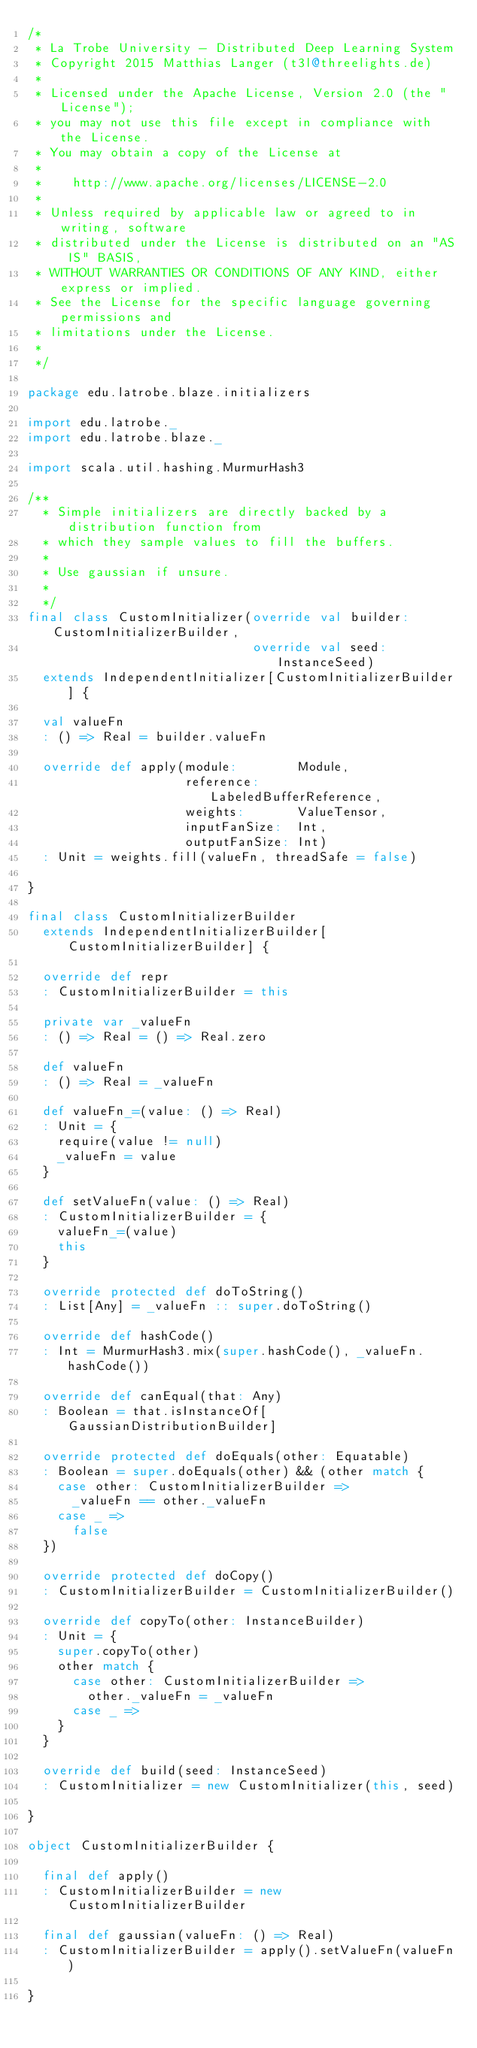<code> <loc_0><loc_0><loc_500><loc_500><_Scala_>/*
 * La Trobe University - Distributed Deep Learning System
 * Copyright 2015 Matthias Langer (t3l@threelights.de)
 *
 * Licensed under the Apache License, Version 2.0 (the "License");
 * you may not use this file except in compliance with the License.
 * You may obtain a copy of the License at
 *
 *    http://www.apache.org/licenses/LICENSE-2.0
 *
 * Unless required by applicable law or agreed to in writing, software
 * distributed under the License is distributed on an "AS IS" BASIS,
 * WITHOUT WARRANTIES OR CONDITIONS OF ANY KIND, either express or implied.
 * See the License for the specific language governing permissions and
 * limitations under the License.
 *
 */

package edu.latrobe.blaze.initializers

import edu.latrobe._
import edu.latrobe.blaze._

import scala.util.hashing.MurmurHash3

/**
  * Simple initializers are directly backed by a distribution function from
  * which they sample values to fill the buffers.
  *
  * Use gaussian if unsure.
  *
  */
final class CustomInitializer(override val builder: CustomInitializerBuilder,
                              override val seed:    InstanceSeed)
  extends IndependentInitializer[CustomInitializerBuilder] {

  val valueFn
  : () => Real = builder.valueFn

  override def apply(module:        Module,
                     reference:     LabeledBufferReference,
                     weights:       ValueTensor,
                     inputFanSize:  Int,
                     outputFanSize: Int)
  : Unit = weights.fill(valueFn, threadSafe = false)

}

final class CustomInitializerBuilder
  extends IndependentInitializerBuilder[CustomInitializerBuilder] {

  override def repr
  : CustomInitializerBuilder = this

  private var _valueFn
  : () => Real = () => Real.zero

  def valueFn
  : () => Real = _valueFn

  def valueFn_=(value: () => Real)
  : Unit = {
    require(value != null)
    _valueFn = value
  }

  def setValueFn(value: () => Real)
  : CustomInitializerBuilder = {
    valueFn_=(value)
    this
  }

  override protected def doToString()
  : List[Any] = _valueFn :: super.doToString()

  override def hashCode()
  : Int = MurmurHash3.mix(super.hashCode(), _valueFn.hashCode())

  override def canEqual(that: Any)
  : Boolean = that.isInstanceOf[GaussianDistributionBuilder]

  override protected def doEquals(other: Equatable)
  : Boolean = super.doEquals(other) && (other match {
    case other: CustomInitializerBuilder =>
      _valueFn == other._valueFn
    case _ =>
      false
  })

  override protected def doCopy()
  : CustomInitializerBuilder = CustomInitializerBuilder()

  override def copyTo(other: InstanceBuilder)
  : Unit = {
    super.copyTo(other)
    other match {
      case other: CustomInitializerBuilder =>
        other._valueFn = _valueFn
      case _ =>
    }
  }

  override def build(seed: InstanceSeed)
  : CustomInitializer = new CustomInitializer(this, seed)

}

object CustomInitializerBuilder {

  final def apply()
  : CustomInitializerBuilder = new CustomInitializerBuilder

  final def gaussian(valueFn: () => Real)
  : CustomInitializerBuilder = apply().setValueFn(valueFn)

}
</code> 